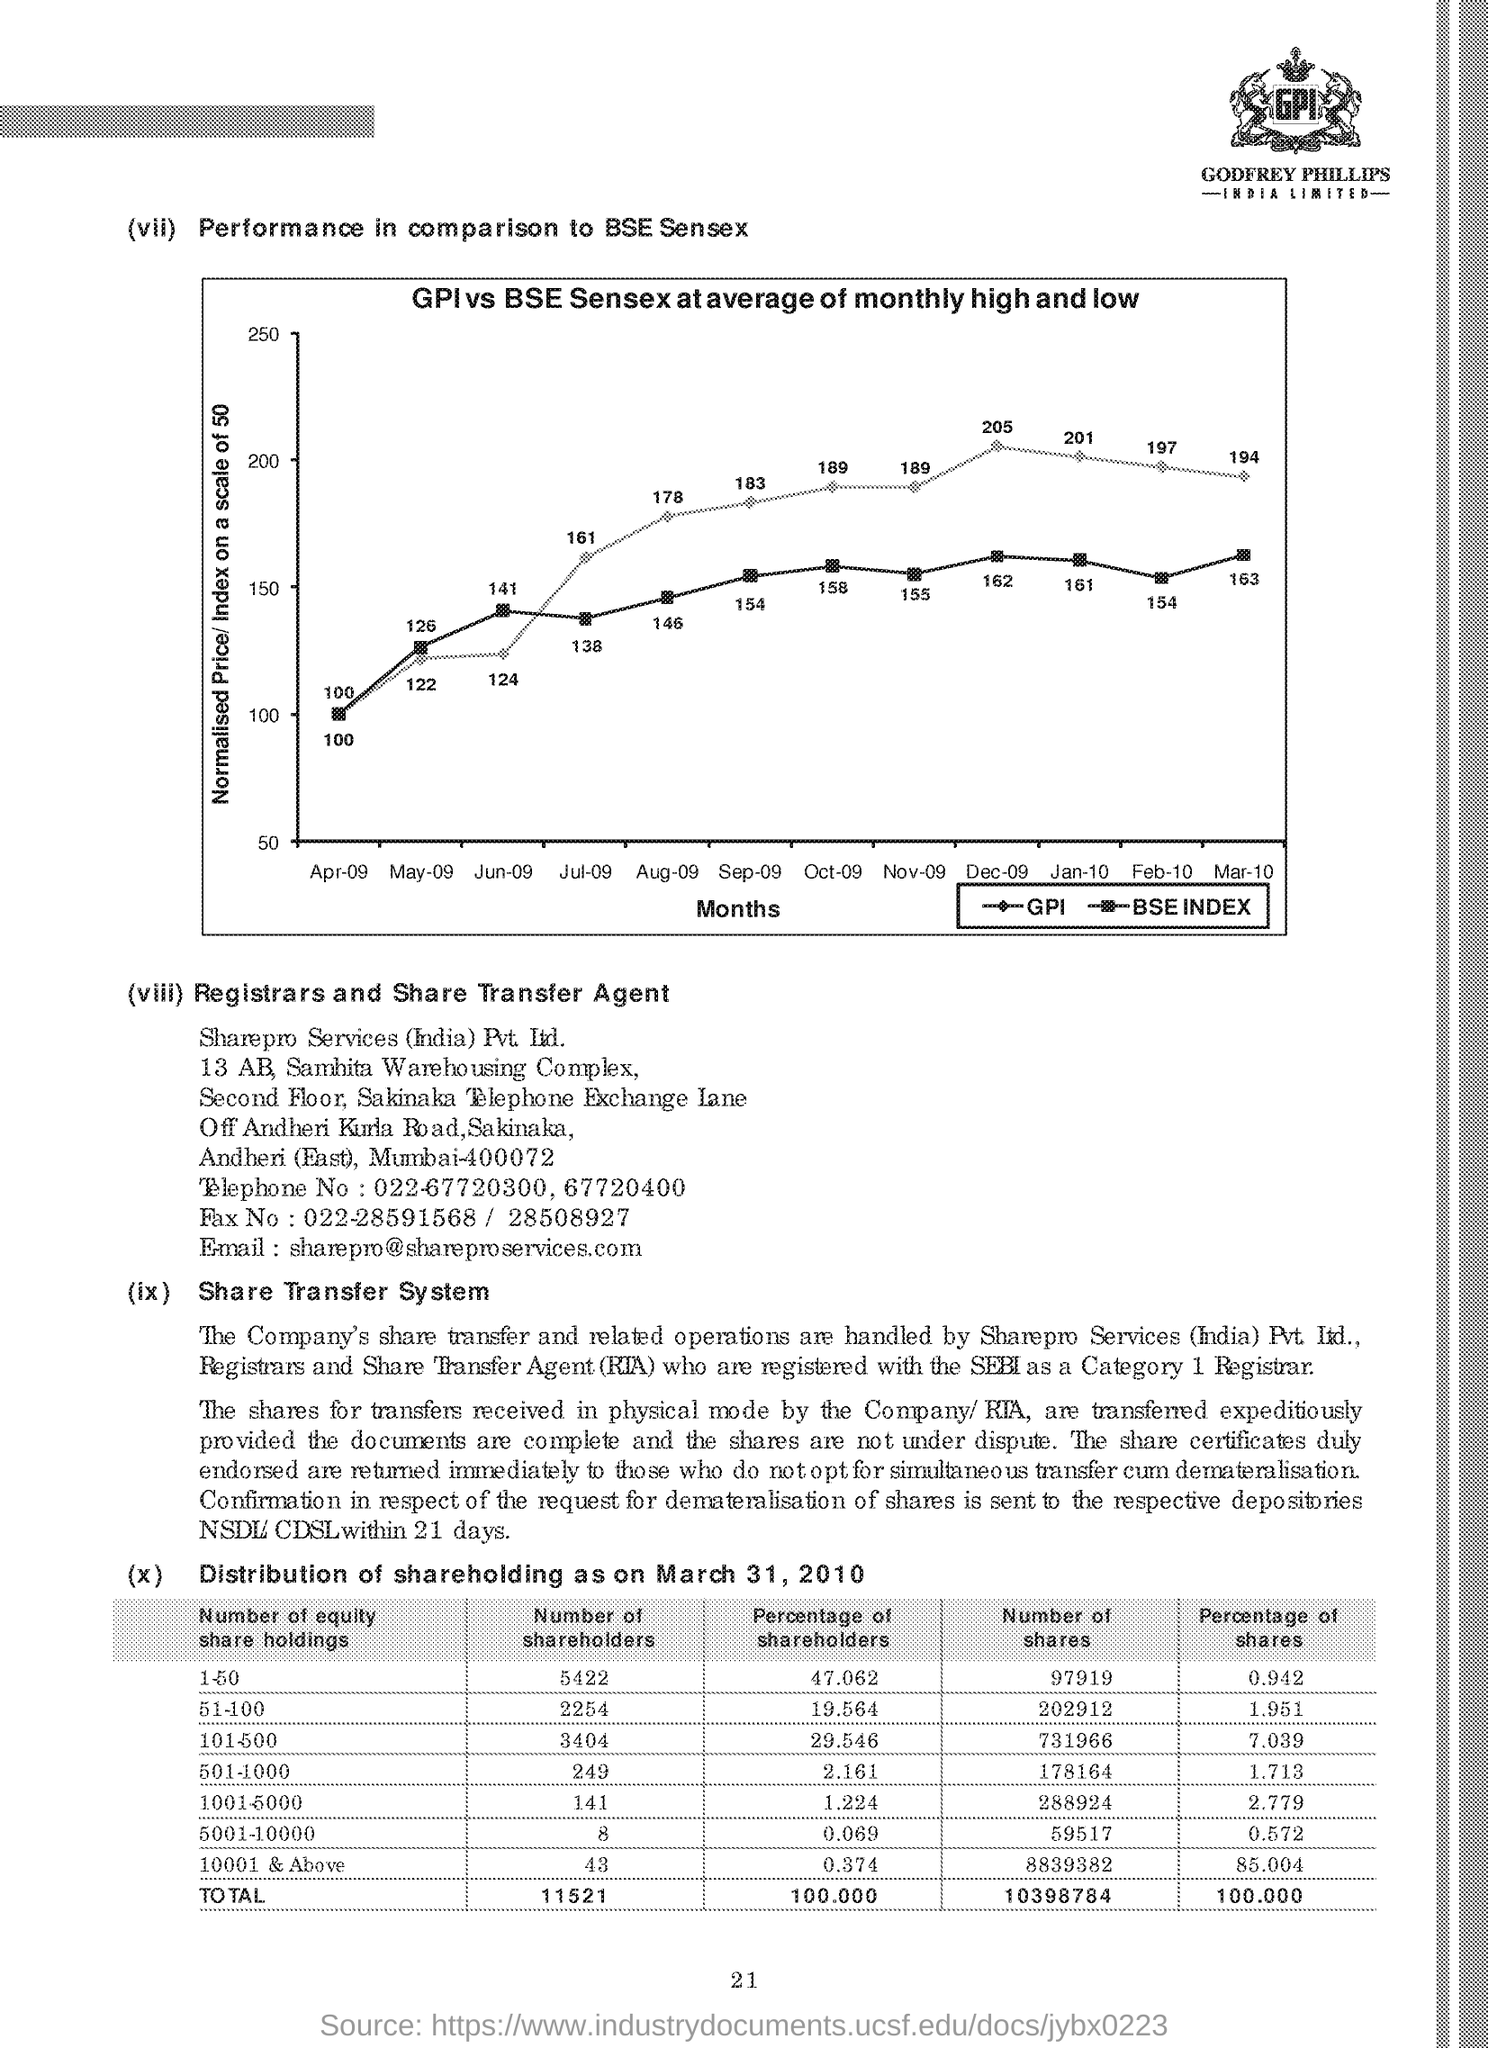What is the performance price of GPI Sensex in month Apr
Your answer should be very brief. 100. What is the performance price of BSESensex in month Jul
Your response must be concise. 138. What is the scale of normalised Price
Keep it short and to the point. 50. 